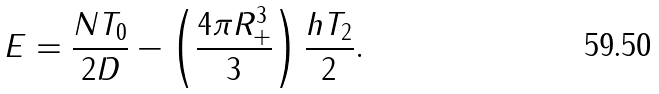<formula> <loc_0><loc_0><loc_500><loc_500>E = \frac { N T _ { 0 } } { 2 D } - \left ( \frac { 4 \pi R _ { + } ^ { 3 } } { 3 } \right ) \frac { h T _ { 2 } } { 2 } .</formula> 